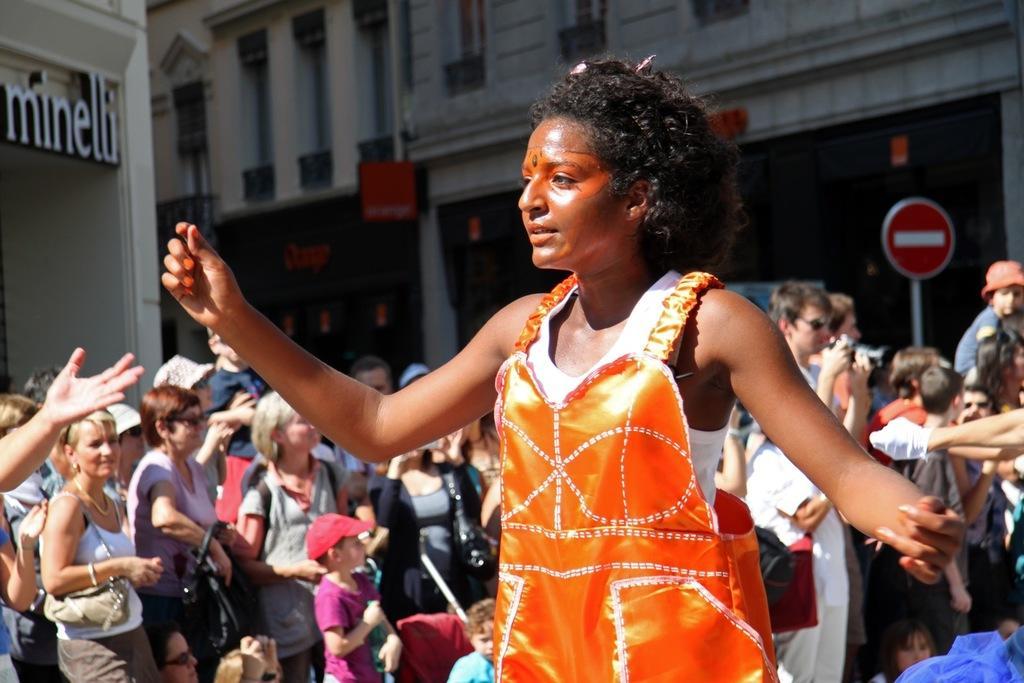Describe this image in one or two sentences. In this image I can see the group of people with different color dresses. I can see few people with hats and caps. I can also see few people holding the bags. In the background there is a sign board and the building. 